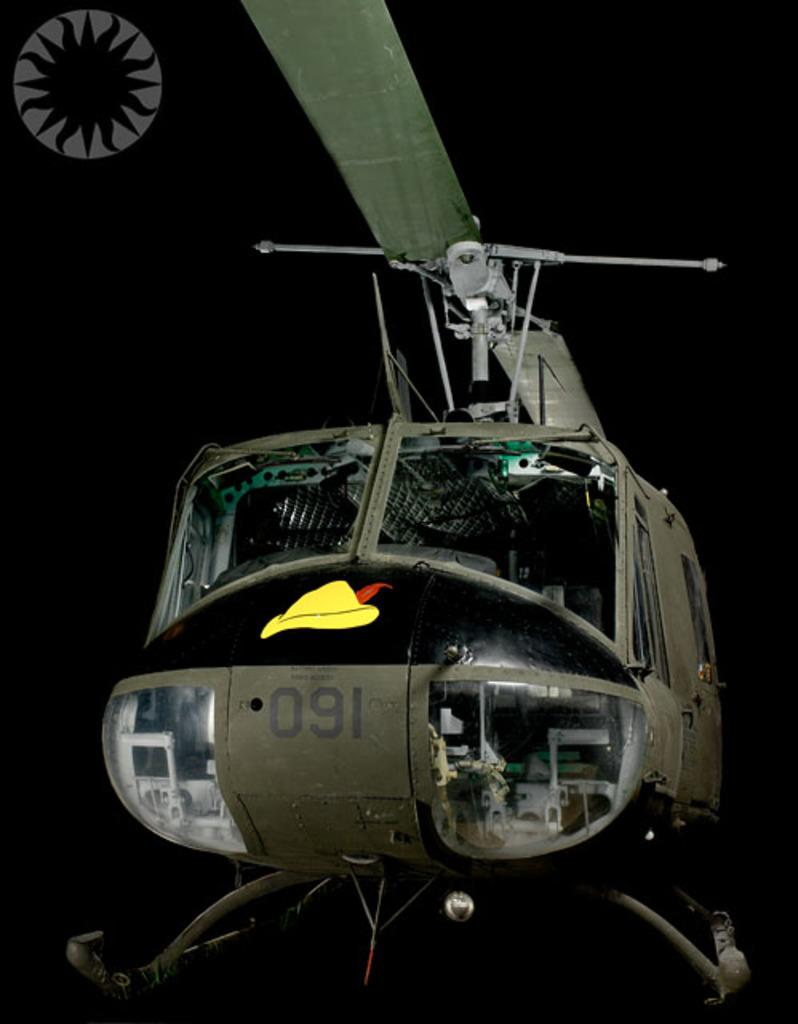<image>
Write a terse but informative summary of the picture. the letters 091 are on the helicopter with dark behind it 